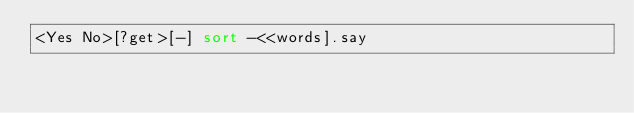Convert code to text. <code><loc_0><loc_0><loc_500><loc_500><_Perl_><Yes No>[?get>[-] sort -<<words].say</code> 